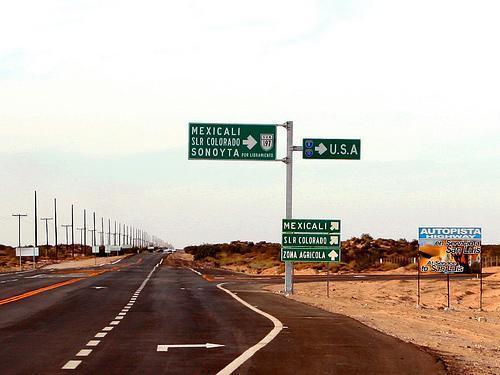How many signs are facing you?
Give a very brief answer. 6. How many cars are there?
Give a very brief answer. 0. 